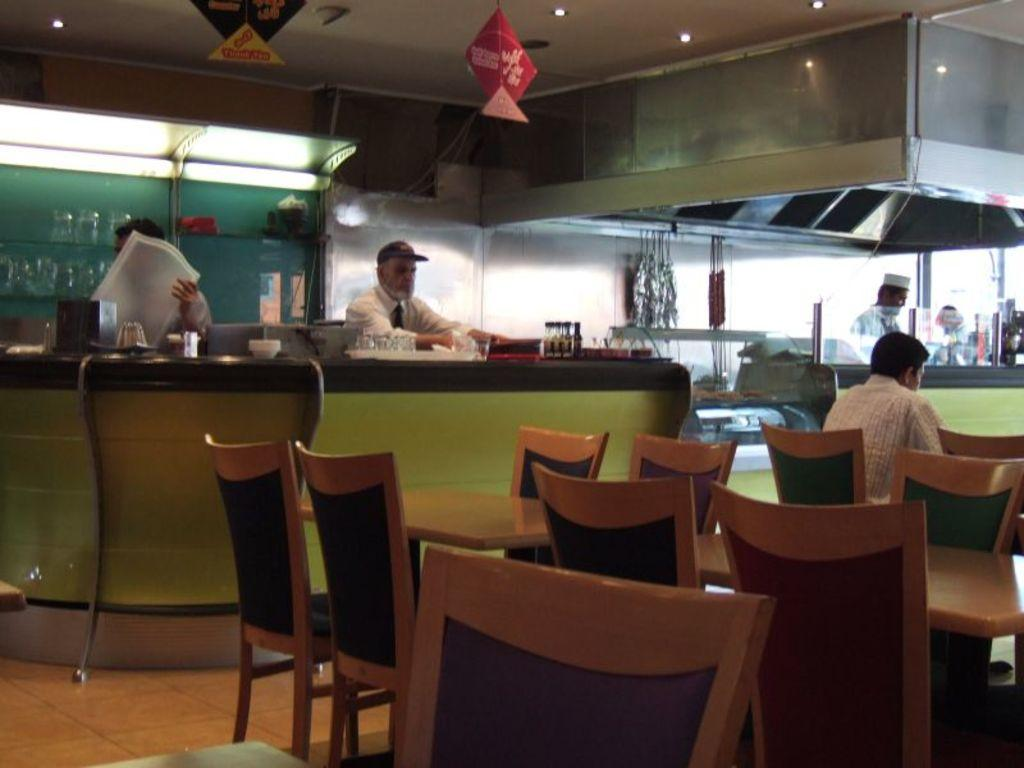What type of establishment is shown in the image? The image depicts a cafeteria. What type of furniture is present in the cafeteria? There are chairs and tables in the image. Is there any other furniture or equipment in the image? Yes, there is a desk in the image. Are there any people present in the cafeteria? Yes, there are people in the image. Can you tell me how many eggs are on the desk in the image? There are no eggs present on the desk in the image. What type of offer is being made by the people in the image? There is no indication of any offer being made by the people in the image. 